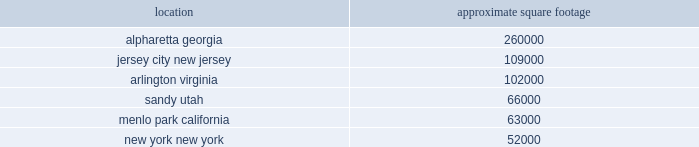Table of contents item 1b .
Unresolved staff comments item 2 .
Properties a summary of our significant locations at december 31 , 2015 is shown in the table .
Square footage amounts are net of space that has been sublet or is part of a facility restructuring. .
All facilities are leased at december 31 , 2015 .
All of our facilities are used by either our trading and investing or balance sheet management segments , in addition to the corporate/other category .
All other leased facilities with space of less than 25000 square feet are not listed by location .
In addition to the significant facilities above , we also lease all 30 regional branches , ranging in space from approximately 2500 to 8000 square feet .
Item 3 .
Legal proceedings information in response to this item can be found under the heading "legal matters" in note 19 2014 commitments , contingencies and other regulatory matters to part ii .
Item 8 .
Financial statements and supplementary data in this annual report and is incorporated by reference into this item .
Item 4 .
Mine safety disclosures not applicable. .
As of december 31 , 2015 what was the ratio of the square footage in alpharetta georgia to jersey city new jersey? 
Rationale: as of december 31 , 2015 there was 2.39 square footage in alpharetta georgia to jersey city new jersey
Computations: (260000 / 109000)
Answer: 2.38532. 